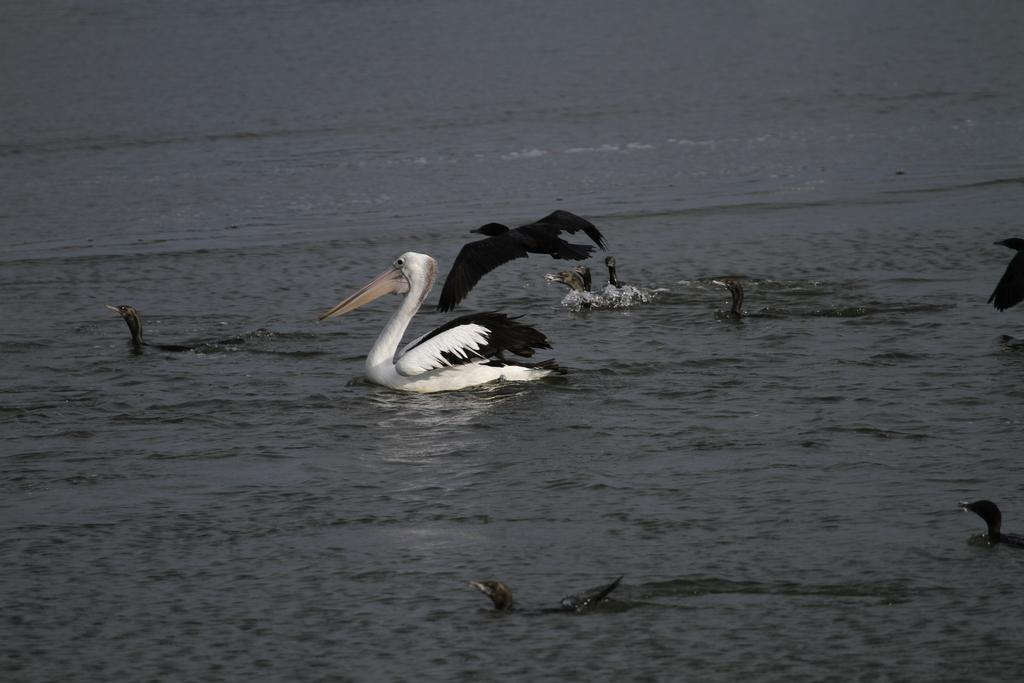What is happening at the bottom of the image? There are two birds swimming in the water at the bottom of the image. What can be seen in the background of the image? There are other birds in the background of the image. Are the birds in the background also swimming in the water? Yes, some of the birds in the background are swimming in the water. Is there a fight between the birds and a shoe in the image? No, there is no fight between the birds and a shoe in the image. There are no shoes present in the image. 